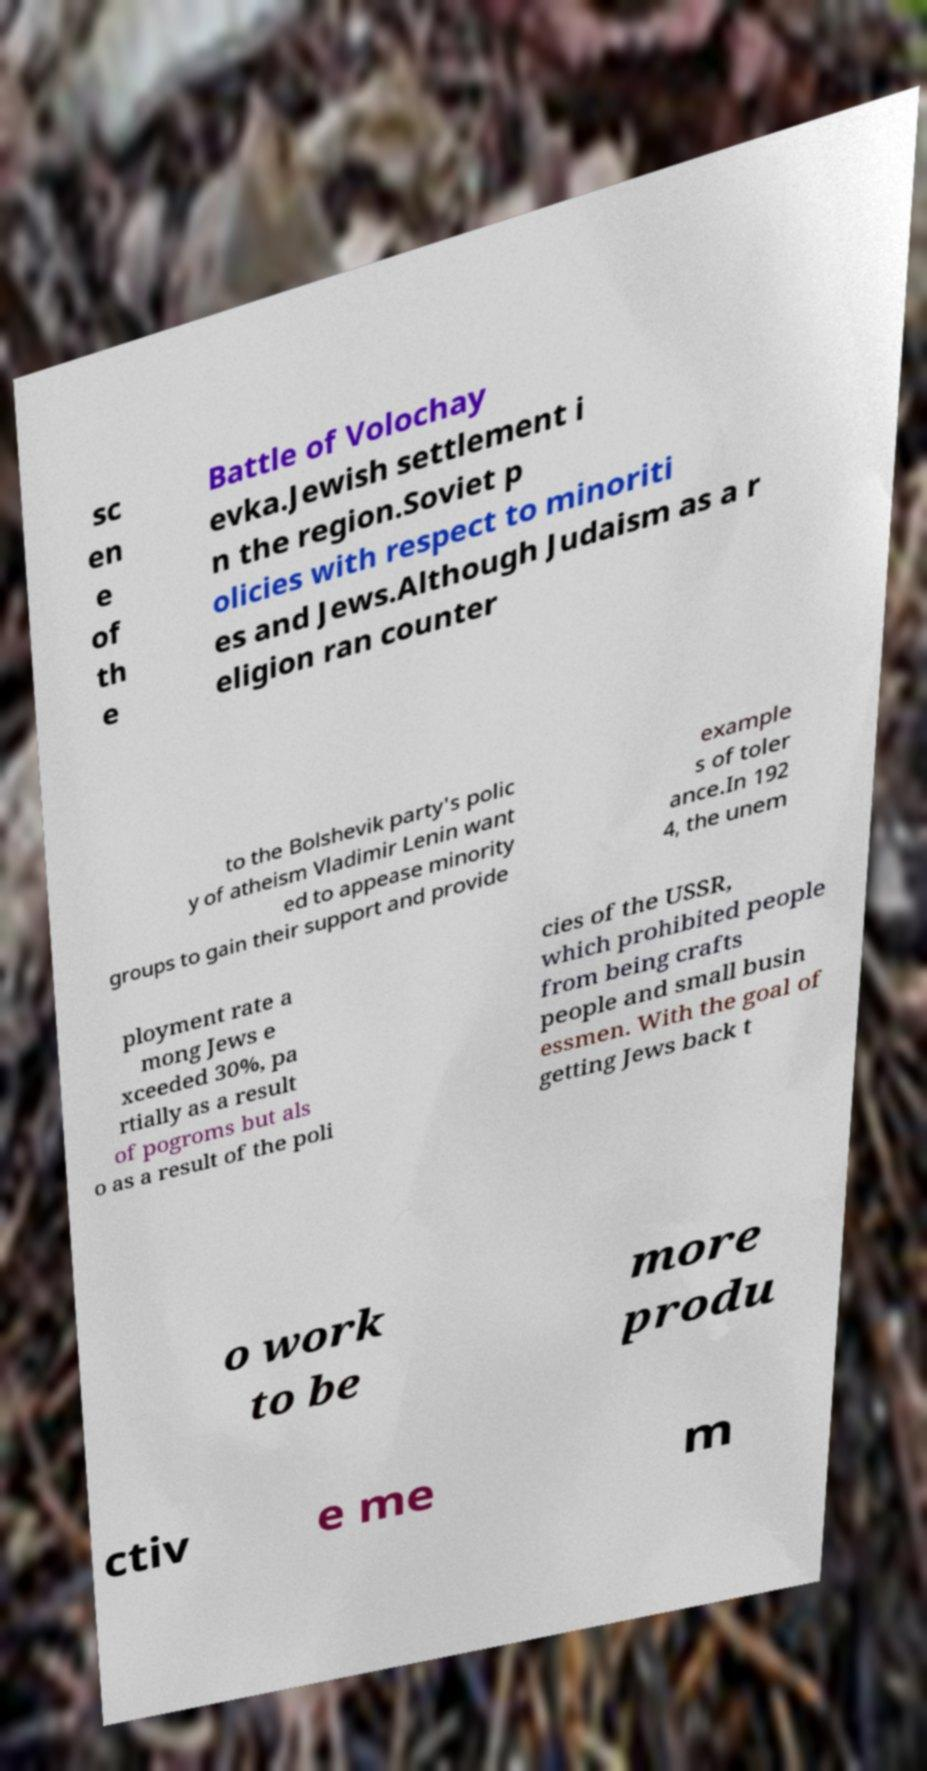What messages or text are displayed in this image? I need them in a readable, typed format. sc en e of th e Battle of Volochay evka.Jewish settlement i n the region.Soviet p olicies with respect to minoriti es and Jews.Although Judaism as a r eligion ran counter to the Bolshevik party's polic y of atheism Vladimir Lenin want ed to appease minority groups to gain their support and provide example s of toler ance.In 192 4, the unem ployment rate a mong Jews e xceeded 30%, pa rtially as a result of pogroms but als o as a result of the poli cies of the USSR, which prohibited people from being crafts people and small busin essmen. With the goal of getting Jews back t o work to be more produ ctiv e me m 